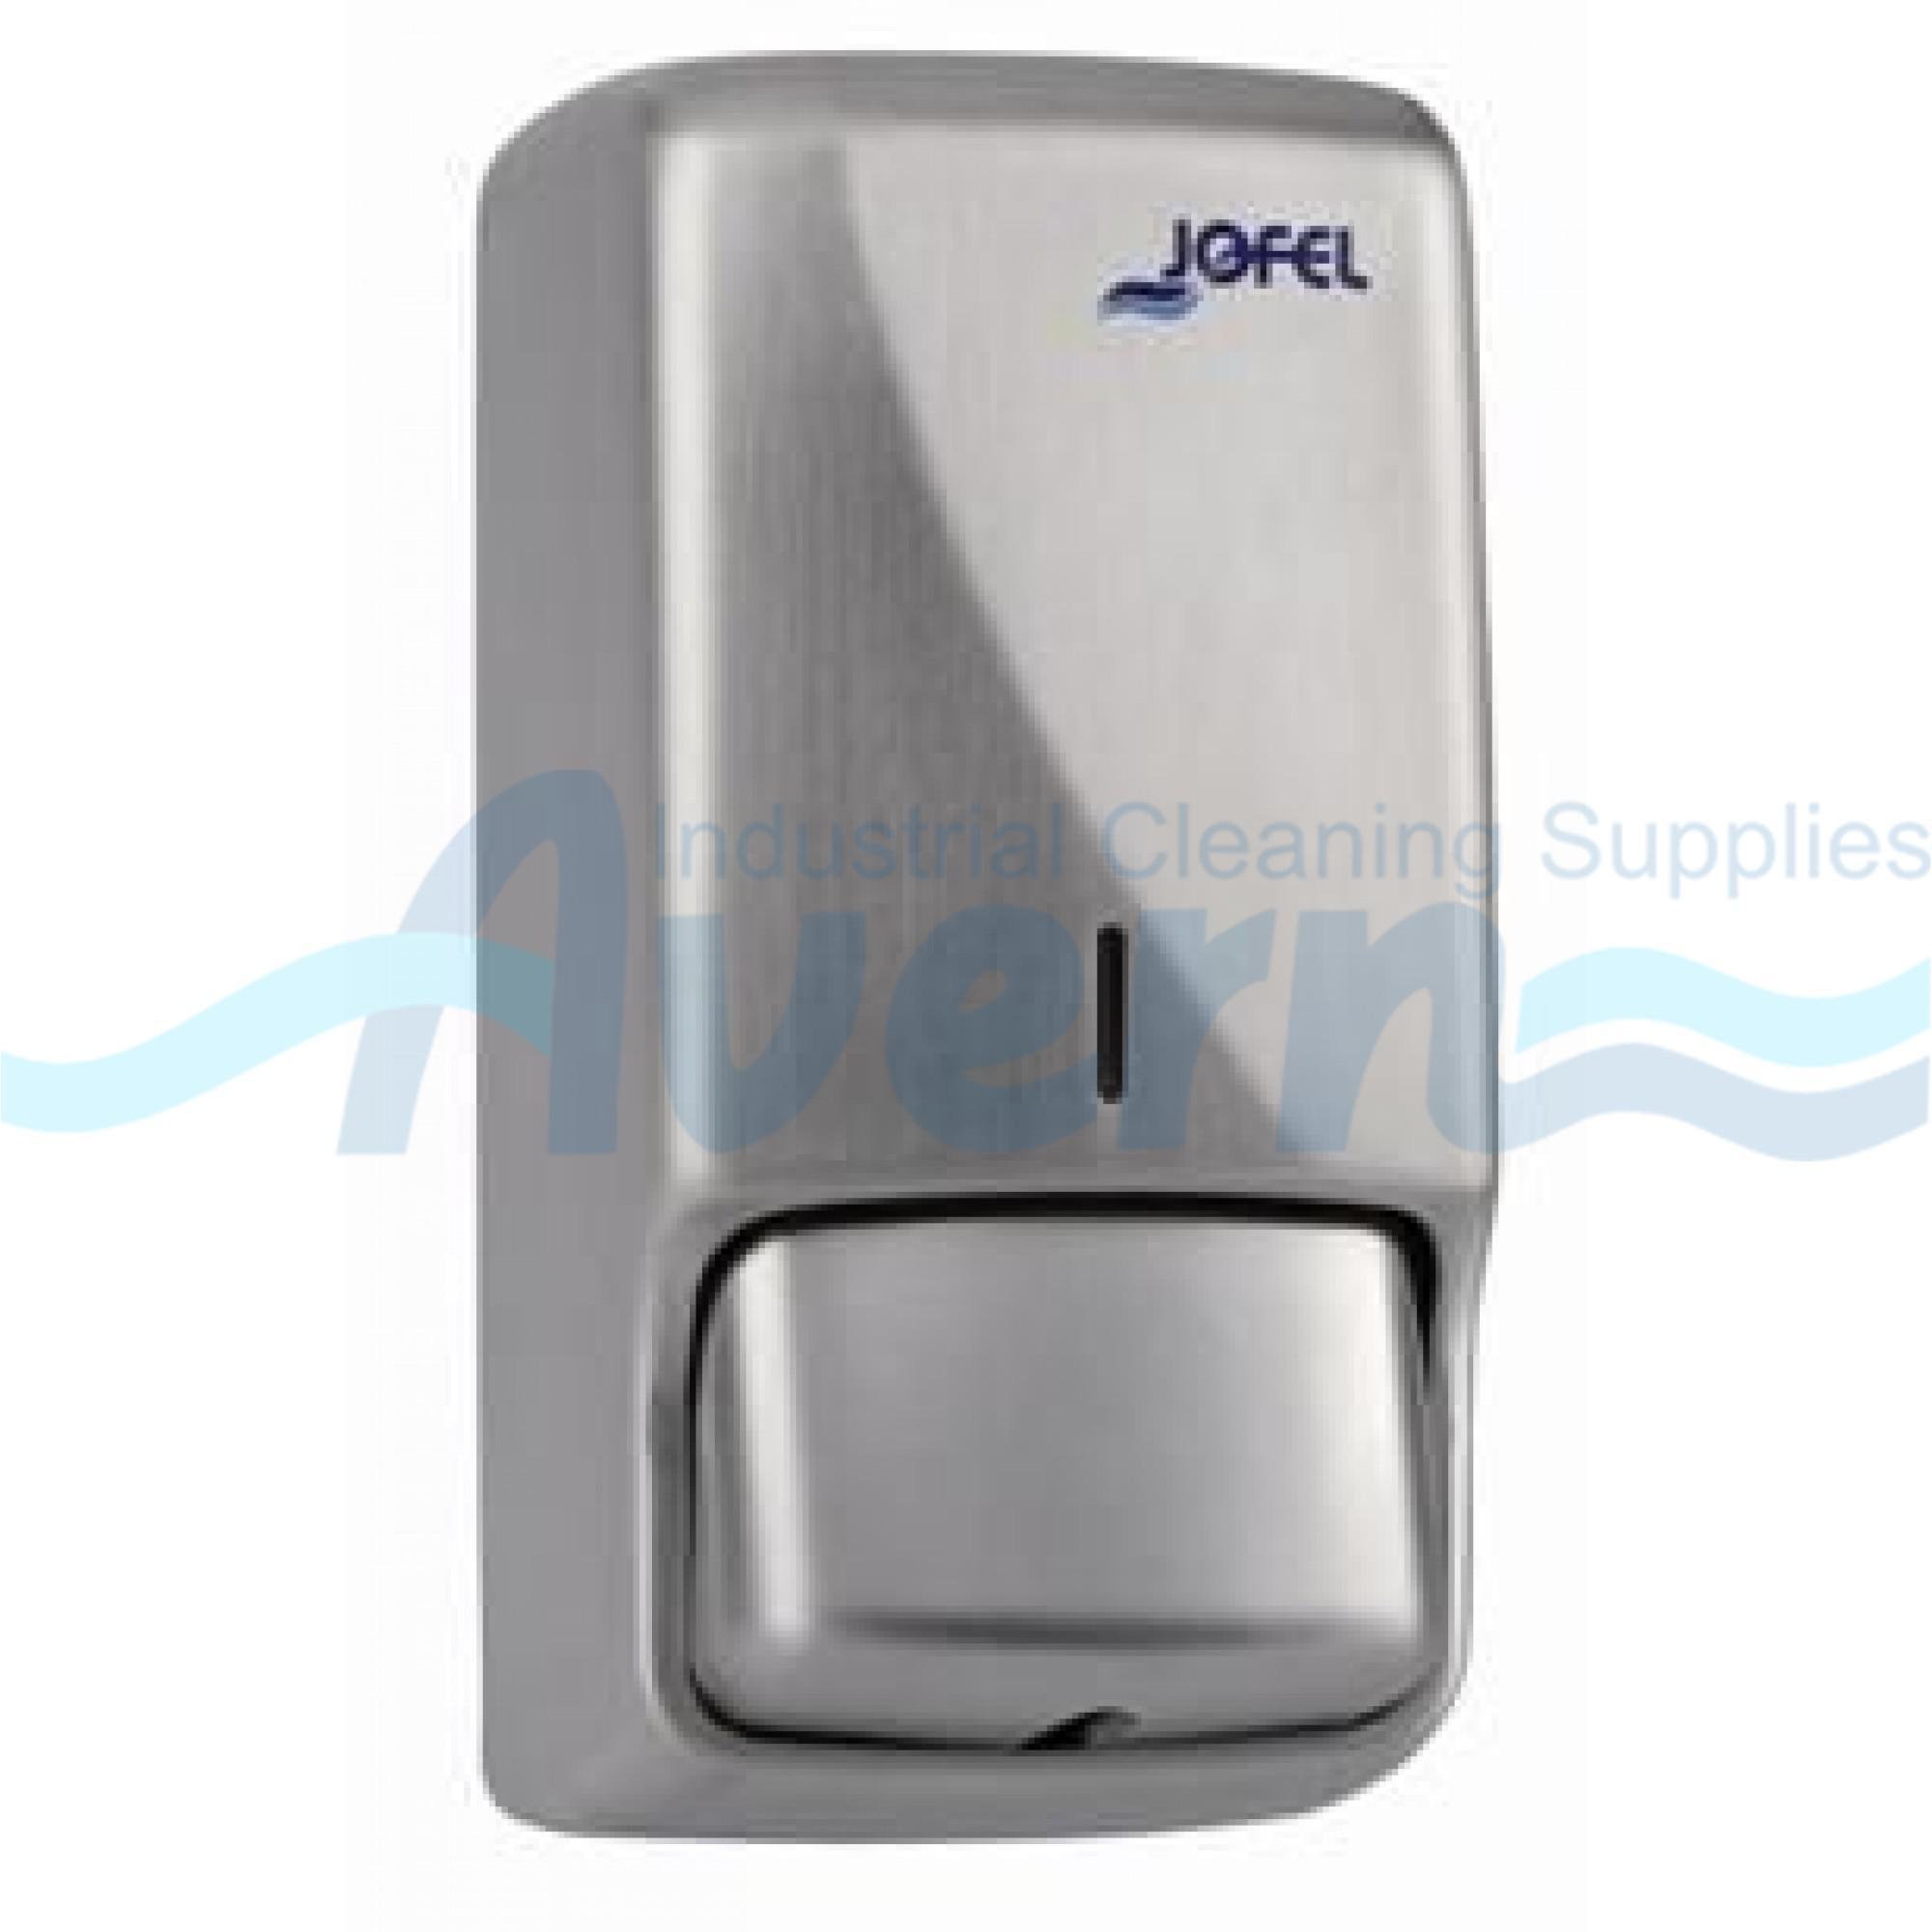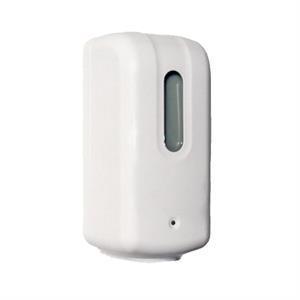The first image is the image on the left, the second image is the image on the right. For the images shown, is this caption "All of the soap dispensers are primarily white." true? Answer yes or no. No. The first image is the image on the left, the second image is the image on the right. Analyze the images presented: Is the assertion "At least one of the soap dispensers is not white." valid? Answer yes or no. Yes. 